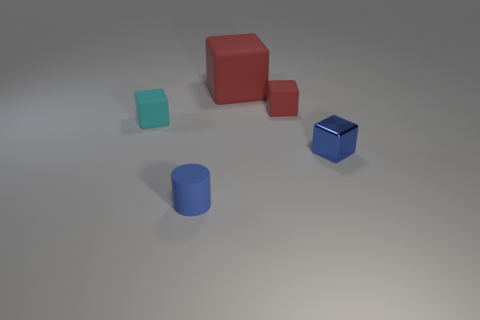Subtract 1 cubes. How many cubes are left? 3 Add 2 small green matte cylinders. How many objects exist? 7 Subtract all cylinders. How many objects are left? 4 Subtract 0 purple cylinders. How many objects are left? 5 Subtract all metallic cylinders. Subtract all tiny blue rubber cylinders. How many objects are left? 4 Add 4 big red objects. How many big red objects are left? 5 Add 5 matte objects. How many matte objects exist? 9 